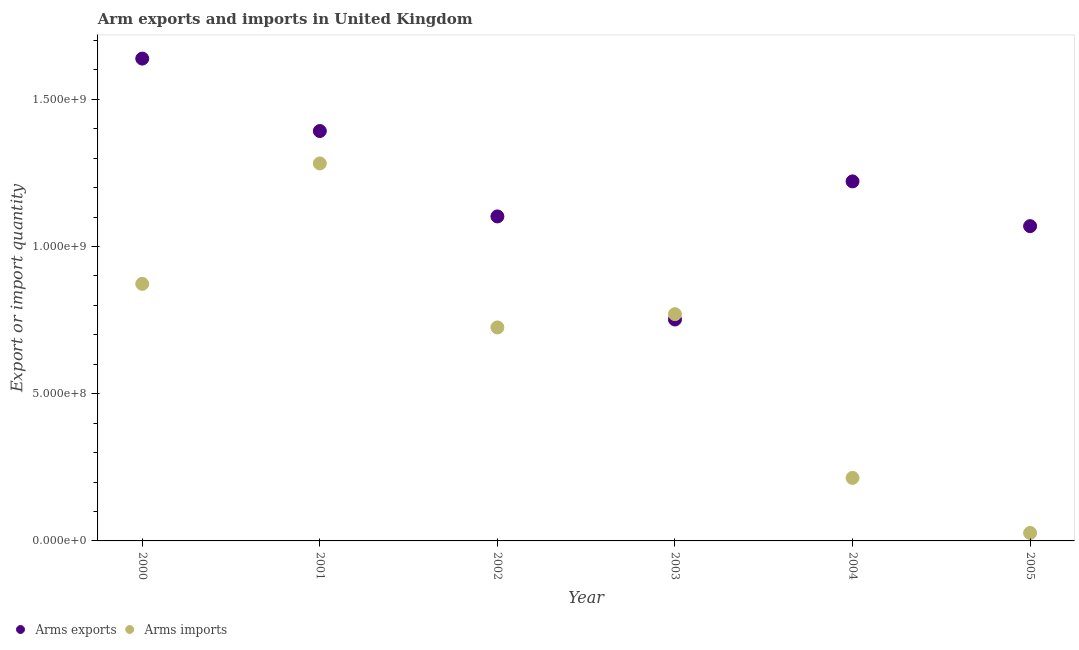How many different coloured dotlines are there?
Make the answer very short. 2. Is the number of dotlines equal to the number of legend labels?
Give a very brief answer. Yes. What is the arms exports in 2004?
Offer a terse response. 1.22e+09. Across all years, what is the maximum arms imports?
Offer a terse response. 1.28e+09. Across all years, what is the minimum arms exports?
Your answer should be compact. 7.52e+08. What is the total arms imports in the graph?
Provide a short and direct response. 3.89e+09. What is the difference between the arms imports in 2000 and that in 2002?
Make the answer very short. 1.48e+08. What is the difference between the arms exports in 2005 and the arms imports in 2004?
Make the answer very short. 8.55e+08. What is the average arms imports per year?
Your answer should be compact. 6.48e+08. In the year 2002, what is the difference between the arms imports and arms exports?
Offer a very short reply. -3.77e+08. In how many years, is the arms exports greater than 300000000?
Make the answer very short. 6. What is the ratio of the arms imports in 2002 to that in 2005?
Keep it short and to the point. 26.85. Is the difference between the arms exports in 2002 and 2004 greater than the difference between the arms imports in 2002 and 2004?
Ensure brevity in your answer.  No. What is the difference between the highest and the second highest arms exports?
Offer a terse response. 2.46e+08. What is the difference between the highest and the lowest arms imports?
Your answer should be very brief. 1.26e+09. Is the sum of the arms imports in 2001 and 2005 greater than the maximum arms exports across all years?
Your response must be concise. No. What is the difference between two consecutive major ticks on the Y-axis?
Offer a very short reply. 5.00e+08. Are the values on the major ticks of Y-axis written in scientific E-notation?
Make the answer very short. Yes. Does the graph contain any zero values?
Make the answer very short. No. Does the graph contain grids?
Provide a succinct answer. No. How many legend labels are there?
Provide a succinct answer. 2. What is the title of the graph?
Offer a terse response. Arm exports and imports in United Kingdom. What is the label or title of the Y-axis?
Give a very brief answer. Export or import quantity. What is the Export or import quantity of Arms exports in 2000?
Provide a succinct answer. 1.64e+09. What is the Export or import quantity in Arms imports in 2000?
Provide a short and direct response. 8.73e+08. What is the Export or import quantity in Arms exports in 2001?
Ensure brevity in your answer.  1.39e+09. What is the Export or import quantity in Arms imports in 2001?
Give a very brief answer. 1.28e+09. What is the Export or import quantity in Arms exports in 2002?
Your answer should be compact. 1.10e+09. What is the Export or import quantity of Arms imports in 2002?
Your answer should be compact. 7.25e+08. What is the Export or import quantity in Arms exports in 2003?
Your response must be concise. 7.52e+08. What is the Export or import quantity of Arms imports in 2003?
Your response must be concise. 7.70e+08. What is the Export or import quantity in Arms exports in 2004?
Keep it short and to the point. 1.22e+09. What is the Export or import quantity in Arms imports in 2004?
Your response must be concise. 2.14e+08. What is the Export or import quantity in Arms exports in 2005?
Your response must be concise. 1.07e+09. What is the Export or import quantity in Arms imports in 2005?
Provide a succinct answer. 2.70e+07. Across all years, what is the maximum Export or import quantity in Arms exports?
Make the answer very short. 1.64e+09. Across all years, what is the maximum Export or import quantity of Arms imports?
Provide a succinct answer. 1.28e+09. Across all years, what is the minimum Export or import quantity of Arms exports?
Give a very brief answer. 7.52e+08. Across all years, what is the minimum Export or import quantity in Arms imports?
Make the answer very short. 2.70e+07. What is the total Export or import quantity in Arms exports in the graph?
Provide a succinct answer. 7.17e+09. What is the total Export or import quantity of Arms imports in the graph?
Provide a succinct answer. 3.89e+09. What is the difference between the Export or import quantity in Arms exports in 2000 and that in 2001?
Provide a short and direct response. 2.46e+08. What is the difference between the Export or import quantity in Arms imports in 2000 and that in 2001?
Ensure brevity in your answer.  -4.09e+08. What is the difference between the Export or import quantity of Arms exports in 2000 and that in 2002?
Provide a succinct answer. 5.36e+08. What is the difference between the Export or import quantity in Arms imports in 2000 and that in 2002?
Provide a short and direct response. 1.48e+08. What is the difference between the Export or import quantity in Arms exports in 2000 and that in 2003?
Keep it short and to the point. 8.86e+08. What is the difference between the Export or import quantity in Arms imports in 2000 and that in 2003?
Provide a succinct answer. 1.03e+08. What is the difference between the Export or import quantity in Arms exports in 2000 and that in 2004?
Make the answer very short. 4.17e+08. What is the difference between the Export or import quantity of Arms imports in 2000 and that in 2004?
Your response must be concise. 6.59e+08. What is the difference between the Export or import quantity of Arms exports in 2000 and that in 2005?
Offer a terse response. 5.69e+08. What is the difference between the Export or import quantity in Arms imports in 2000 and that in 2005?
Provide a succinct answer. 8.46e+08. What is the difference between the Export or import quantity of Arms exports in 2001 and that in 2002?
Provide a short and direct response. 2.90e+08. What is the difference between the Export or import quantity in Arms imports in 2001 and that in 2002?
Provide a succinct answer. 5.57e+08. What is the difference between the Export or import quantity of Arms exports in 2001 and that in 2003?
Provide a succinct answer. 6.40e+08. What is the difference between the Export or import quantity in Arms imports in 2001 and that in 2003?
Ensure brevity in your answer.  5.12e+08. What is the difference between the Export or import quantity in Arms exports in 2001 and that in 2004?
Offer a very short reply. 1.71e+08. What is the difference between the Export or import quantity of Arms imports in 2001 and that in 2004?
Make the answer very short. 1.07e+09. What is the difference between the Export or import quantity in Arms exports in 2001 and that in 2005?
Offer a very short reply. 3.23e+08. What is the difference between the Export or import quantity in Arms imports in 2001 and that in 2005?
Give a very brief answer. 1.26e+09. What is the difference between the Export or import quantity in Arms exports in 2002 and that in 2003?
Keep it short and to the point. 3.50e+08. What is the difference between the Export or import quantity of Arms imports in 2002 and that in 2003?
Give a very brief answer. -4.50e+07. What is the difference between the Export or import quantity in Arms exports in 2002 and that in 2004?
Your answer should be very brief. -1.19e+08. What is the difference between the Export or import quantity in Arms imports in 2002 and that in 2004?
Your answer should be compact. 5.11e+08. What is the difference between the Export or import quantity in Arms exports in 2002 and that in 2005?
Keep it short and to the point. 3.30e+07. What is the difference between the Export or import quantity in Arms imports in 2002 and that in 2005?
Your response must be concise. 6.98e+08. What is the difference between the Export or import quantity in Arms exports in 2003 and that in 2004?
Keep it short and to the point. -4.69e+08. What is the difference between the Export or import quantity in Arms imports in 2003 and that in 2004?
Provide a succinct answer. 5.56e+08. What is the difference between the Export or import quantity in Arms exports in 2003 and that in 2005?
Provide a succinct answer. -3.17e+08. What is the difference between the Export or import quantity of Arms imports in 2003 and that in 2005?
Your response must be concise. 7.43e+08. What is the difference between the Export or import quantity in Arms exports in 2004 and that in 2005?
Make the answer very short. 1.52e+08. What is the difference between the Export or import quantity in Arms imports in 2004 and that in 2005?
Ensure brevity in your answer.  1.87e+08. What is the difference between the Export or import quantity in Arms exports in 2000 and the Export or import quantity in Arms imports in 2001?
Provide a succinct answer. 3.56e+08. What is the difference between the Export or import quantity in Arms exports in 2000 and the Export or import quantity in Arms imports in 2002?
Provide a succinct answer. 9.13e+08. What is the difference between the Export or import quantity of Arms exports in 2000 and the Export or import quantity of Arms imports in 2003?
Ensure brevity in your answer.  8.68e+08. What is the difference between the Export or import quantity of Arms exports in 2000 and the Export or import quantity of Arms imports in 2004?
Give a very brief answer. 1.42e+09. What is the difference between the Export or import quantity of Arms exports in 2000 and the Export or import quantity of Arms imports in 2005?
Provide a succinct answer. 1.61e+09. What is the difference between the Export or import quantity in Arms exports in 2001 and the Export or import quantity in Arms imports in 2002?
Offer a very short reply. 6.67e+08. What is the difference between the Export or import quantity in Arms exports in 2001 and the Export or import quantity in Arms imports in 2003?
Your answer should be compact. 6.22e+08. What is the difference between the Export or import quantity of Arms exports in 2001 and the Export or import quantity of Arms imports in 2004?
Provide a short and direct response. 1.18e+09. What is the difference between the Export or import quantity in Arms exports in 2001 and the Export or import quantity in Arms imports in 2005?
Make the answer very short. 1.36e+09. What is the difference between the Export or import quantity of Arms exports in 2002 and the Export or import quantity of Arms imports in 2003?
Your answer should be compact. 3.32e+08. What is the difference between the Export or import quantity in Arms exports in 2002 and the Export or import quantity in Arms imports in 2004?
Keep it short and to the point. 8.88e+08. What is the difference between the Export or import quantity in Arms exports in 2002 and the Export or import quantity in Arms imports in 2005?
Offer a very short reply. 1.08e+09. What is the difference between the Export or import quantity of Arms exports in 2003 and the Export or import quantity of Arms imports in 2004?
Give a very brief answer. 5.38e+08. What is the difference between the Export or import quantity of Arms exports in 2003 and the Export or import quantity of Arms imports in 2005?
Your answer should be very brief. 7.25e+08. What is the difference between the Export or import quantity in Arms exports in 2004 and the Export or import quantity in Arms imports in 2005?
Your answer should be very brief. 1.19e+09. What is the average Export or import quantity in Arms exports per year?
Ensure brevity in your answer.  1.20e+09. What is the average Export or import quantity of Arms imports per year?
Offer a terse response. 6.48e+08. In the year 2000, what is the difference between the Export or import quantity of Arms exports and Export or import quantity of Arms imports?
Offer a terse response. 7.65e+08. In the year 2001, what is the difference between the Export or import quantity of Arms exports and Export or import quantity of Arms imports?
Provide a short and direct response. 1.10e+08. In the year 2002, what is the difference between the Export or import quantity of Arms exports and Export or import quantity of Arms imports?
Make the answer very short. 3.77e+08. In the year 2003, what is the difference between the Export or import quantity of Arms exports and Export or import quantity of Arms imports?
Your response must be concise. -1.80e+07. In the year 2004, what is the difference between the Export or import quantity of Arms exports and Export or import quantity of Arms imports?
Make the answer very short. 1.01e+09. In the year 2005, what is the difference between the Export or import quantity of Arms exports and Export or import quantity of Arms imports?
Ensure brevity in your answer.  1.04e+09. What is the ratio of the Export or import quantity of Arms exports in 2000 to that in 2001?
Keep it short and to the point. 1.18. What is the ratio of the Export or import quantity of Arms imports in 2000 to that in 2001?
Offer a terse response. 0.68. What is the ratio of the Export or import quantity of Arms exports in 2000 to that in 2002?
Keep it short and to the point. 1.49. What is the ratio of the Export or import quantity in Arms imports in 2000 to that in 2002?
Your answer should be compact. 1.2. What is the ratio of the Export or import quantity of Arms exports in 2000 to that in 2003?
Make the answer very short. 2.18. What is the ratio of the Export or import quantity of Arms imports in 2000 to that in 2003?
Ensure brevity in your answer.  1.13. What is the ratio of the Export or import quantity of Arms exports in 2000 to that in 2004?
Provide a short and direct response. 1.34. What is the ratio of the Export or import quantity of Arms imports in 2000 to that in 2004?
Provide a short and direct response. 4.08. What is the ratio of the Export or import quantity in Arms exports in 2000 to that in 2005?
Provide a short and direct response. 1.53. What is the ratio of the Export or import quantity of Arms imports in 2000 to that in 2005?
Ensure brevity in your answer.  32.33. What is the ratio of the Export or import quantity in Arms exports in 2001 to that in 2002?
Your answer should be compact. 1.26. What is the ratio of the Export or import quantity of Arms imports in 2001 to that in 2002?
Offer a very short reply. 1.77. What is the ratio of the Export or import quantity in Arms exports in 2001 to that in 2003?
Your answer should be compact. 1.85. What is the ratio of the Export or import quantity in Arms imports in 2001 to that in 2003?
Your answer should be very brief. 1.66. What is the ratio of the Export or import quantity of Arms exports in 2001 to that in 2004?
Your answer should be very brief. 1.14. What is the ratio of the Export or import quantity of Arms imports in 2001 to that in 2004?
Your response must be concise. 5.99. What is the ratio of the Export or import quantity of Arms exports in 2001 to that in 2005?
Ensure brevity in your answer.  1.3. What is the ratio of the Export or import quantity of Arms imports in 2001 to that in 2005?
Your response must be concise. 47.48. What is the ratio of the Export or import quantity of Arms exports in 2002 to that in 2003?
Offer a terse response. 1.47. What is the ratio of the Export or import quantity of Arms imports in 2002 to that in 2003?
Give a very brief answer. 0.94. What is the ratio of the Export or import quantity in Arms exports in 2002 to that in 2004?
Ensure brevity in your answer.  0.9. What is the ratio of the Export or import quantity of Arms imports in 2002 to that in 2004?
Your answer should be very brief. 3.39. What is the ratio of the Export or import quantity of Arms exports in 2002 to that in 2005?
Offer a very short reply. 1.03. What is the ratio of the Export or import quantity of Arms imports in 2002 to that in 2005?
Your answer should be very brief. 26.85. What is the ratio of the Export or import quantity in Arms exports in 2003 to that in 2004?
Provide a short and direct response. 0.62. What is the ratio of the Export or import quantity in Arms imports in 2003 to that in 2004?
Ensure brevity in your answer.  3.6. What is the ratio of the Export or import quantity of Arms exports in 2003 to that in 2005?
Provide a short and direct response. 0.7. What is the ratio of the Export or import quantity of Arms imports in 2003 to that in 2005?
Offer a terse response. 28.52. What is the ratio of the Export or import quantity in Arms exports in 2004 to that in 2005?
Offer a very short reply. 1.14. What is the ratio of the Export or import quantity in Arms imports in 2004 to that in 2005?
Your answer should be compact. 7.93. What is the difference between the highest and the second highest Export or import quantity of Arms exports?
Make the answer very short. 2.46e+08. What is the difference between the highest and the second highest Export or import quantity of Arms imports?
Provide a succinct answer. 4.09e+08. What is the difference between the highest and the lowest Export or import quantity in Arms exports?
Give a very brief answer. 8.86e+08. What is the difference between the highest and the lowest Export or import quantity of Arms imports?
Make the answer very short. 1.26e+09. 